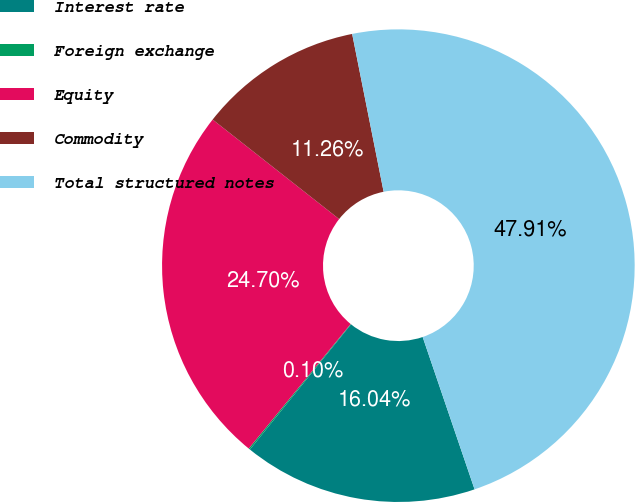Convert chart. <chart><loc_0><loc_0><loc_500><loc_500><pie_chart><fcel>Interest rate<fcel>Foreign exchange<fcel>Equity<fcel>Commodity<fcel>Total structured notes<nl><fcel>16.04%<fcel>0.1%<fcel>24.7%<fcel>11.26%<fcel>47.91%<nl></chart> 